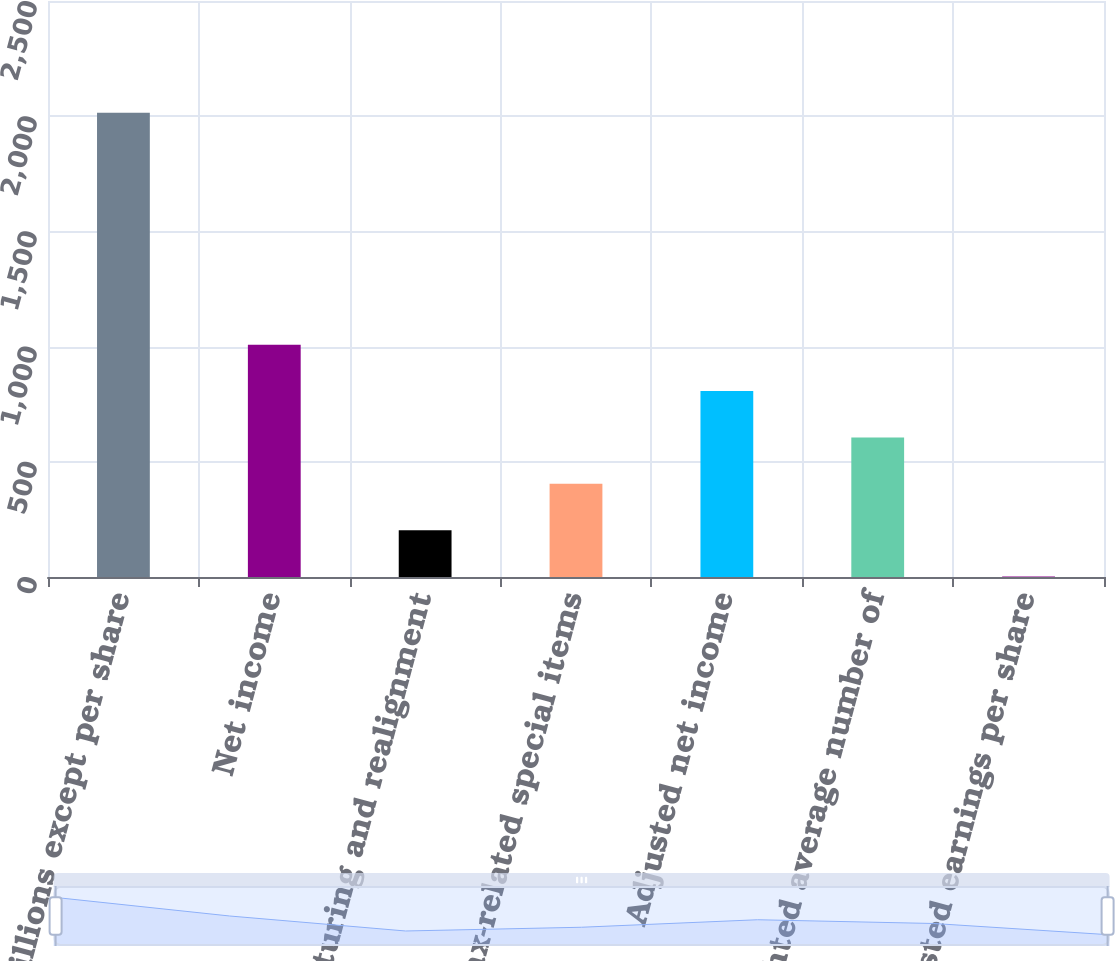<chart> <loc_0><loc_0><loc_500><loc_500><bar_chart><fcel>(in millions except per share<fcel>Net income<fcel>Restructuring and realignment<fcel>Tax-related special items<fcel>Adjusted net income<fcel>Weighted average number of<fcel>Adjusted earnings per share<nl><fcel>2015<fcel>1008.44<fcel>203.17<fcel>404.49<fcel>807.12<fcel>605.81<fcel>1.85<nl></chart> 